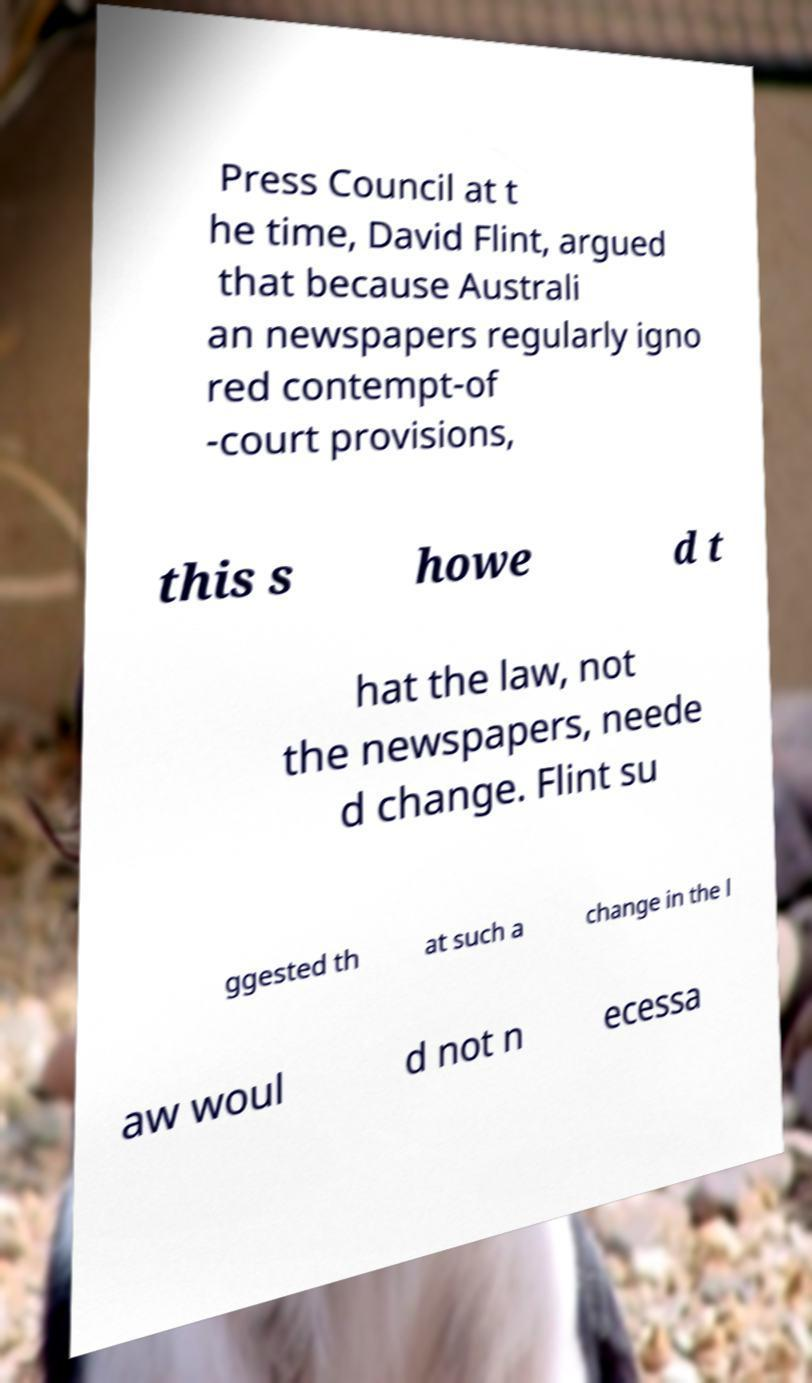There's text embedded in this image that I need extracted. Can you transcribe it verbatim? Press Council at t he time, David Flint, argued that because Australi an newspapers regularly igno red contempt-of -court provisions, this s howe d t hat the law, not the newspapers, neede d change. Flint su ggested th at such a change in the l aw woul d not n ecessa 